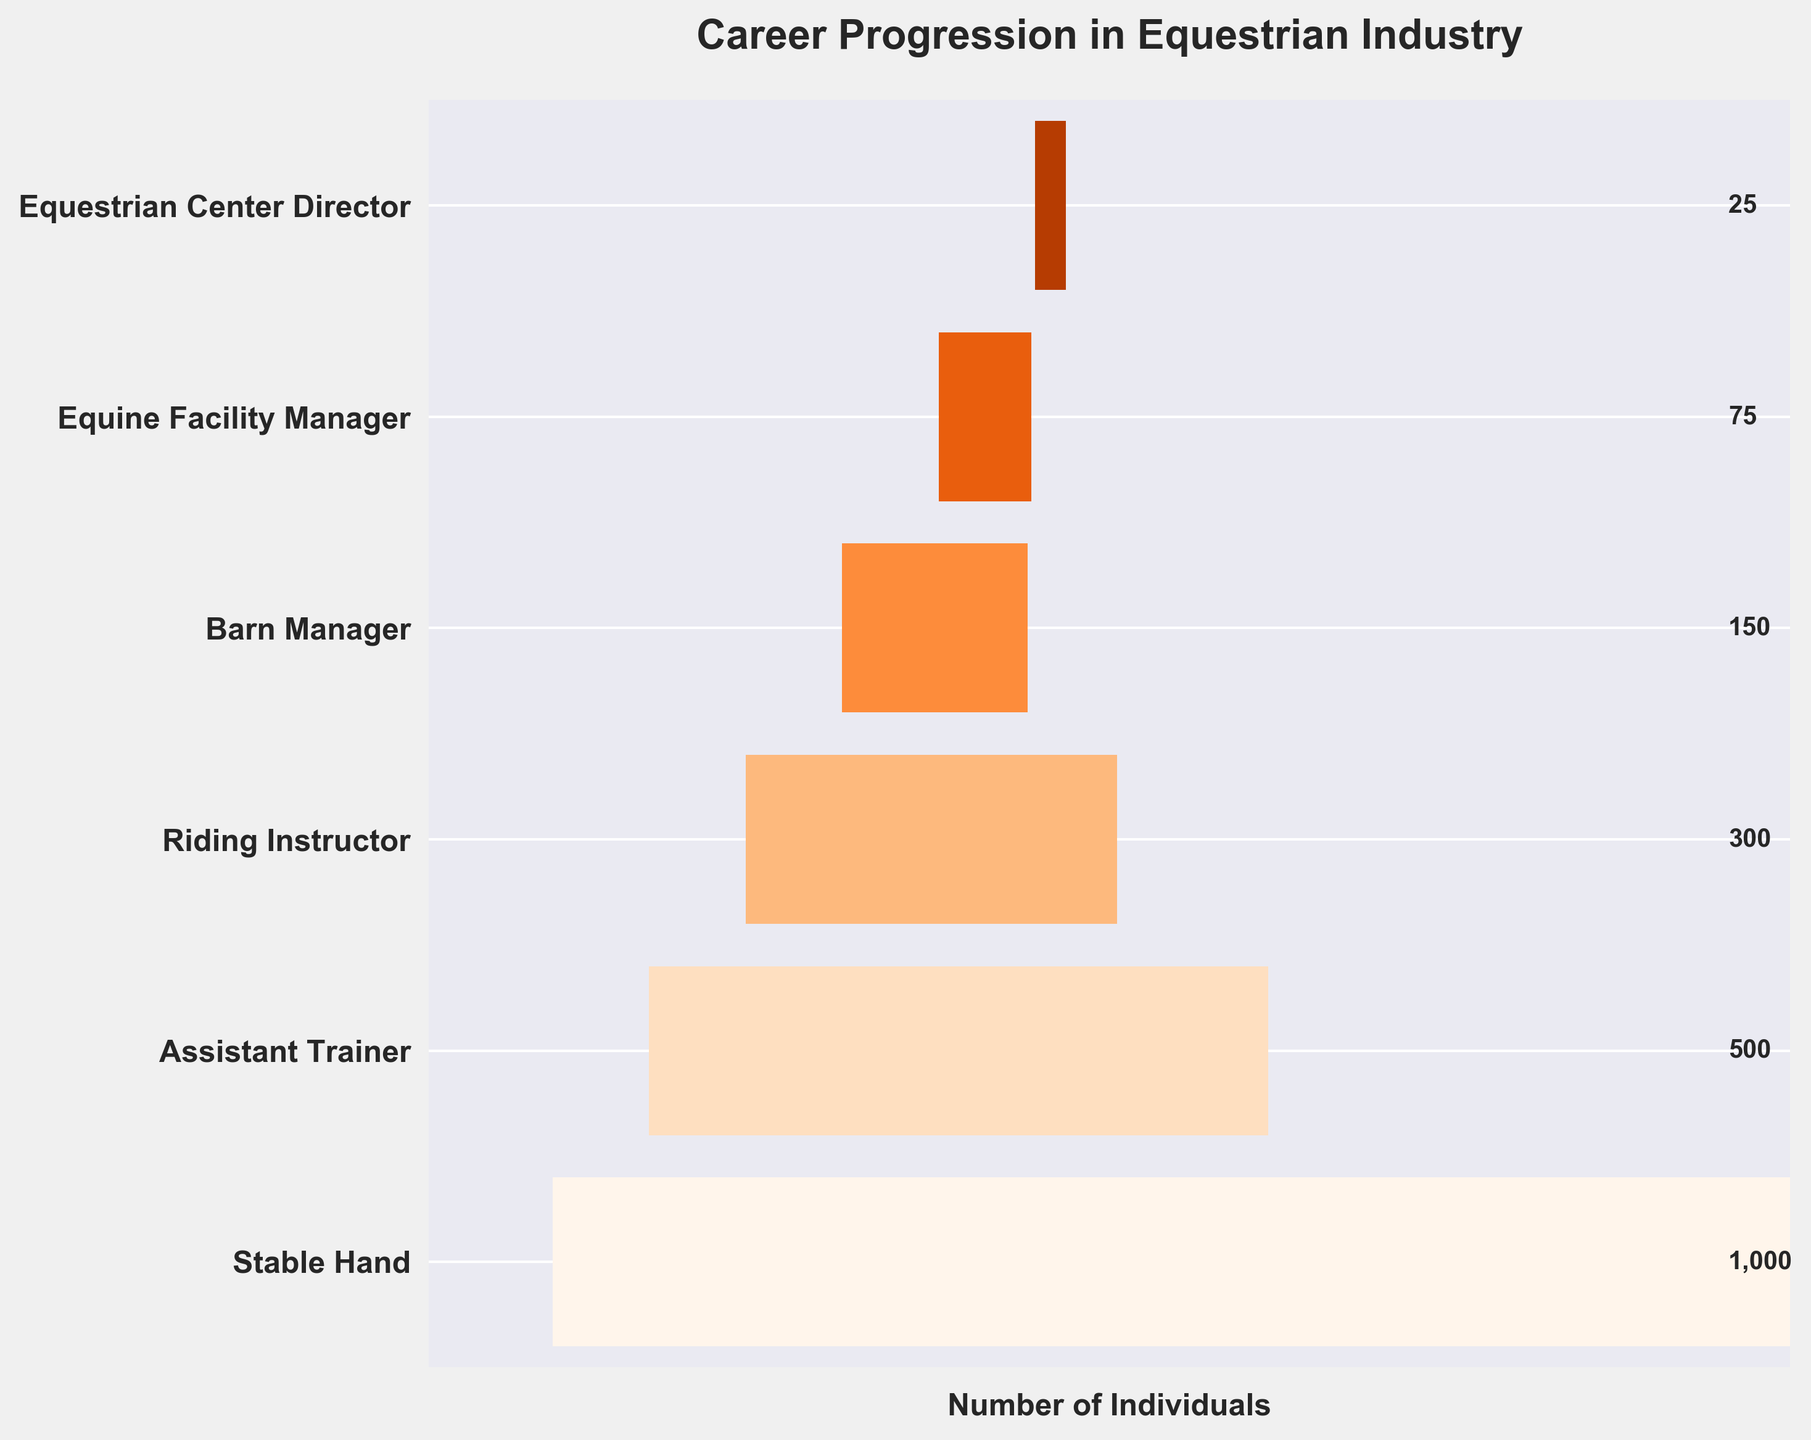What is the title of the funnel chart? The title of the funnel chart is typically displayed at the top of the figure.
Answer: Career Progression in Equestrian Industry How many stages are shown in the career progression? The number of stages can be determined by counting the distinct sections or levels in the funnel chart.
Answer: 6 Which stage has the smallest number of individuals? To find the stage with the smallest number of individuals, look for the narrowest section of the funnel chart.
Answer: Equestrian Center Director What is the difference in the number of individuals between Stable Hand and Barn Manager? Subtract the number of individuals at the Barn Manager stage from the number of individuals at the Stable Hand stage.
Answer: 1000 - 150 = 850 How many individuals are in the Assistant Trainer stage? Check the specific section of the funnel chart labeled as "Assistant Trainer" to find the number of individuals.
Answer: 500 What is the sum of the individuals from Riding Instructor and Equine Facility Manager stages? Add the number of individuals in the Riding Instructor stage to the number in the Equine Facility Manager stage.
Answer: 300 + 75 = 375 What is the ratio of individuals between the highest and lowest stages? Divide the number of individuals in the Stable Hand stage by the number in the Equestrian Center Director stage.
Answer: 1000 / 25 = 40 Which stage shows a 50% reduction in the number of individuals compared to the previous stage? Compare each stage with the following one to see which has half the number of individuals of its previous stage.
Answer: Assistant Trainer to Riding Instructor What percentage of the total individuals are in the Equine Facility Manager stage? Calculate the total number of individuals and then find the percentage that the Equine Facility Manager stage represents of this total.
Answer: (75 / 2050) * 100 ≈ 3.66% How does the width of the section change from the Stable Hand to the Equine Facility Manager? Observe how the funnel narrows from the Stable Hand section to the Equine Facility Manager section, indicating fewer individuals.
Answer: The width narrows significantly as the number of individuals decreases 